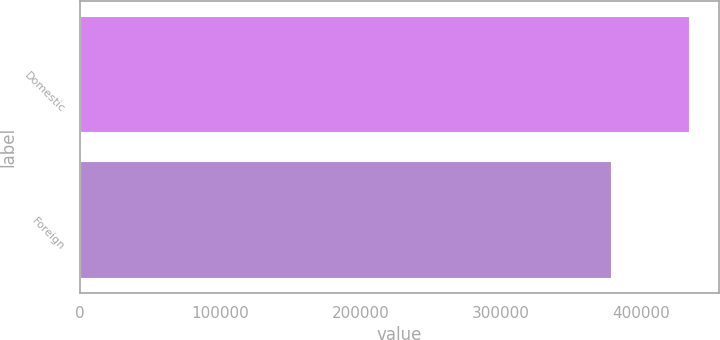Convert chart to OTSL. <chart><loc_0><loc_0><loc_500><loc_500><bar_chart><fcel>Domestic<fcel>Foreign<nl><fcel>434349<fcel>378773<nl></chart> 